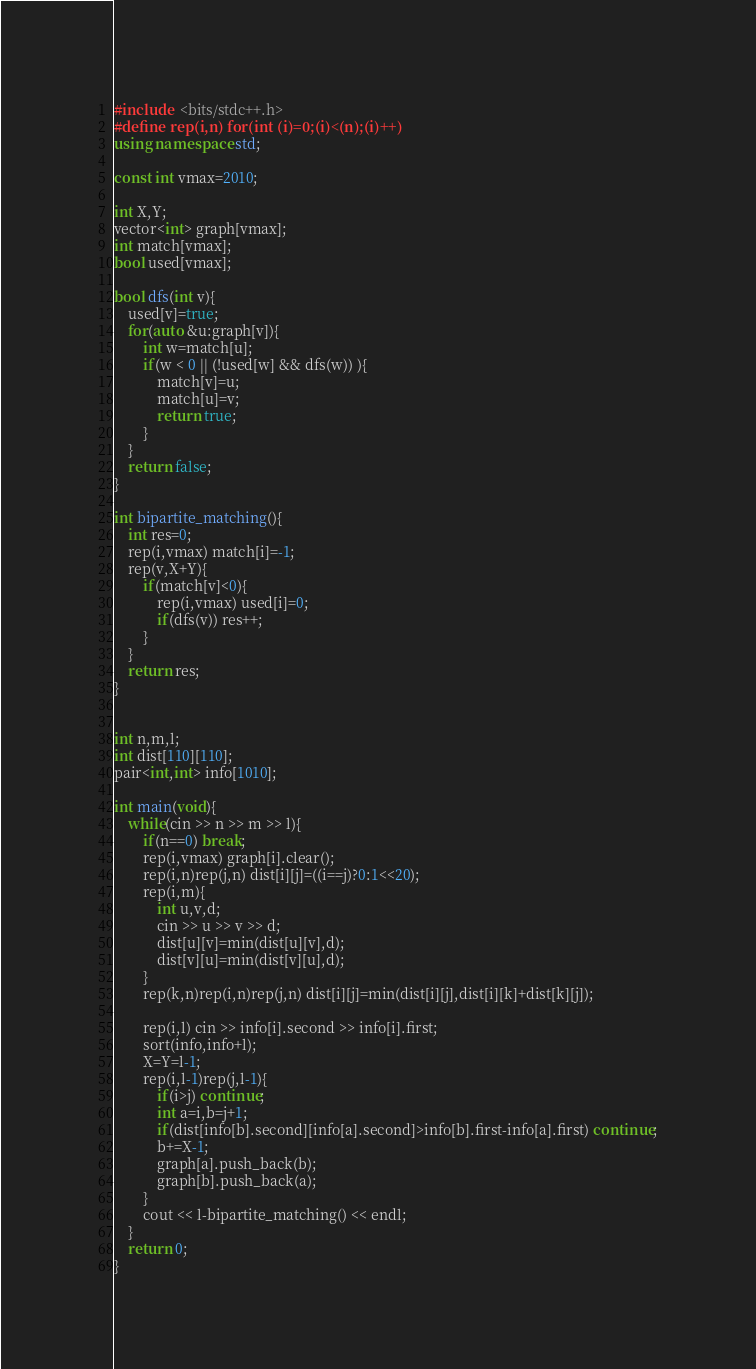Convert code to text. <code><loc_0><loc_0><loc_500><loc_500><_C++_>#include  <bits/stdc++.h>
#define rep(i,n) for(int (i)=0;(i)<(n);(i)++)
using namespace std;

const int vmax=2010;

int X,Y;
vector<int> graph[vmax];
int match[vmax];
bool used[vmax];

bool dfs(int v){
	used[v]=true;
	for(auto &u:graph[v]){
		int w=match[u];
		if(w < 0 || (!used[w] && dfs(w)) ){
			match[v]=u;
			match[u]=v;
			return true;
		}
	}
	return false;
}

int bipartite_matching(){
	int res=0;
	rep(i,vmax) match[i]=-1;
	rep(v,X+Y){
		if(match[v]<0){
			rep(i,vmax) used[i]=0;
			if(dfs(v)) res++;
		}
	}
	return res;
}


int n,m,l;
int dist[110][110];
pair<int,int> info[1010];

int main(void){
	while(cin >> n >> m >> l){
		if(n==0) break;
		rep(i,vmax) graph[i].clear();
		rep(i,n)rep(j,n) dist[i][j]=((i==j)?0:1<<20);
		rep(i,m){
			int u,v,d;
			cin >> u >> v >> d;
			dist[u][v]=min(dist[u][v],d);
			dist[v][u]=min(dist[v][u],d);
		}
		rep(k,n)rep(i,n)rep(j,n) dist[i][j]=min(dist[i][j],dist[i][k]+dist[k][j]);

		rep(i,l) cin >> info[i].second >> info[i].first;
		sort(info,info+l);
		X=Y=l-1;
		rep(i,l-1)rep(j,l-1){
			if(i>j) continue;
			int a=i,b=j+1;
			if(dist[info[b].second][info[a].second]>info[b].first-info[a].first) continue;
			b+=X-1;
			graph[a].push_back(b);
			graph[b].push_back(a);
		}
		cout << l-bipartite_matching() << endl;
	}
	return 0;
}</code> 